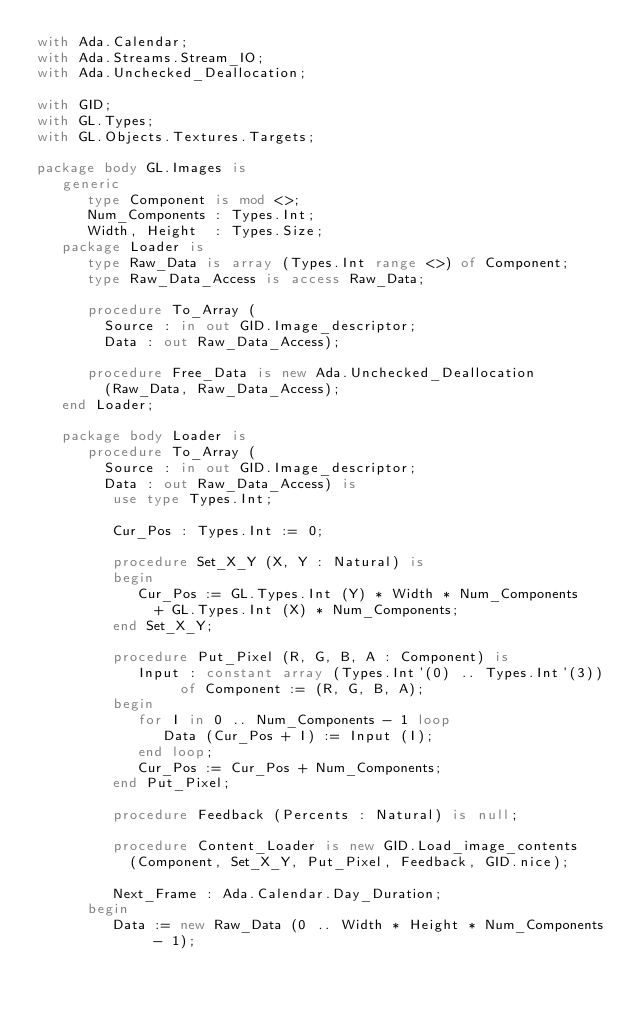<code> <loc_0><loc_0><loc_500><loc_500><_Ada_>with Ada.Calendar;
with Ada.Streams.Stream_IO;
with Ada.Unchecked_Deallocation;

with GID;
with GL.Types;
with GL.Objects.Textures.Targets;

package body GL.Images is
   generic
      type Component is mod <>;
      Num_Components : Types.Int;
      Width, Height  : Types.Size;
   package Loader is
      type Raw_Data is array (Types.Int range <>) of Component;
      type Raw_Data_Access is access Raw_Data;
         
      procedure To_Array (
        Source : in out GID.Image_descriptor;
        Data : out Raw_Data_Access);
        
      procedure Free_Data is new Ada.Unchecked_Deallocation
        (Raw_Data, Raw_Data_Access);
   end Loader;
     
   package body Loader is
      procedure To_Array (
        Source : in out GID.Image_descriptor;
        Data : out Raw_Data_Access) is
         use type Types.Int;
           
         Cur_Pos : Types.Int := 0;
         
         procedure Set_X_Y (X, Y : Natural) is
         begin
            Cur_Pos := GL.Types.Int (Y) * Width * Num_Components
              + GL.Types.Int (X) * Num_Components;
         end Set_X_Y;
         
         procedure Put_Pixel (R, G, B, A : Component) is
            Input : constant array (Types.Int'(0) .. Types.Int'(3)) of Component := (R, G, B, A);
         begin
            for I in 0 .. Num_Components - 1 loop
               Data (Cur_Pos + I) := Input (I);
            end loop;
            Cur_Pos := Cur_Pos + Num_Components;
         end Put_Pixel;
         
         procedure Feedback (Percents : Natural) is null;
         
         procedure Content_Loader is new GID.Load_image_contents
           (Component, Set_X_Y, Put_Pixel, Feedback, GID.nice);
           
         Next_Frame : Ada.Calendar.Day_Duration;
      begin
         Data := new Raw_Data (0 .. Width * Height * Num_Components - 1);</code> 